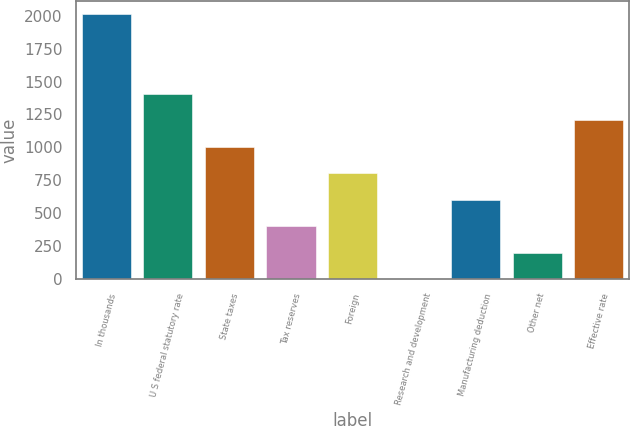<chart> <loc_0><loc_0><loc_500><loc_500><bar_chart><fcel>In thousands<fcel>U S federal statutory rate<fcel>State taxes<fcel>Tax reserves<fcel>Foreign<fcel>Research and development<fcel>Manufacturing deduction<fcel>Other net<fcel>Effective rate<nl><fcel>2012<fcel>1408.46<fcel>1006.1<fcel>402.56<fcel>804.92<fcel>0.2<fcel>603.74<fcel>201.38<fcel>1207.28<nl></chart> 